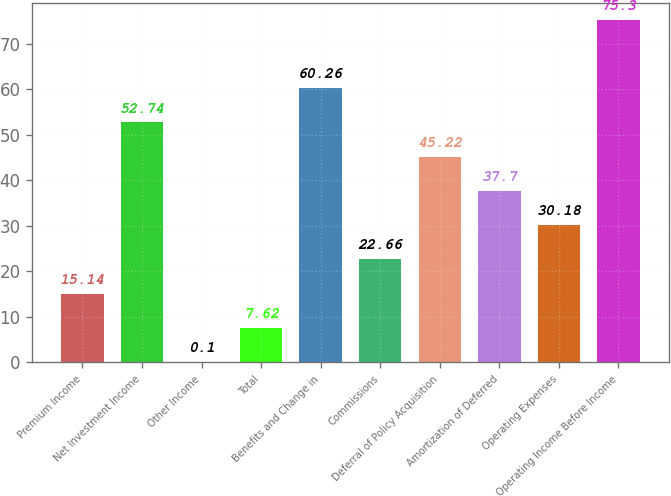<chart> <loc_0><loc_0><loc_500><loc_500><bar_chart><fcel>Premium Income<fcel>Net Investment Income<fcel>Other Income<fcel>Total<fcel>Benefits and Change in<fcel>Commissions<fcel>Deferral of Policy Acquisition<fcel>Amortization of Deferred<fcel>Operating Expenses<fcel>Operating Income Before Income<nl><fcel>15.14<fcel>52.74<fcel>0.1<fcel>7.62<fcel>60.26<fcel>22.66<fcel>45.22<fcel>37.7<fcel>30.18<fcel>75.3<nl></chart> 